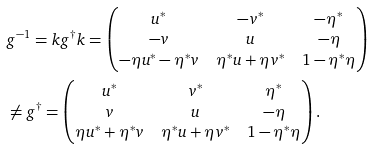<formula> <loc_0><loc_0><loc_500><loc_500>& g ^ { - 1 } = k g ^ { \dagger } k = \begin{pmatrix} u ^ { * } & - v ^ { * } & - \eta ^ { * } \\ - v & u & - \eta \\ - \eta u ^ { * } - \eta ^ { * } v & \eta ^ { * } u + \eta v ^ { * } & 1 - \eta ^ { * } \eta \end{pmatrix} \\ & \neq g ^ { \dagger } = \begin{pmatrix} u ^ { * } & v ^ { * } & \eta ^ { * } \\ v & u & - \eta \\ \eta u ^ { * } + \eta ^ { * } v & \eta ^ { * } u + \eta v ^ { * } & 1 - \eta ^ { * } \eta \end{pmatrix} .</formula> 